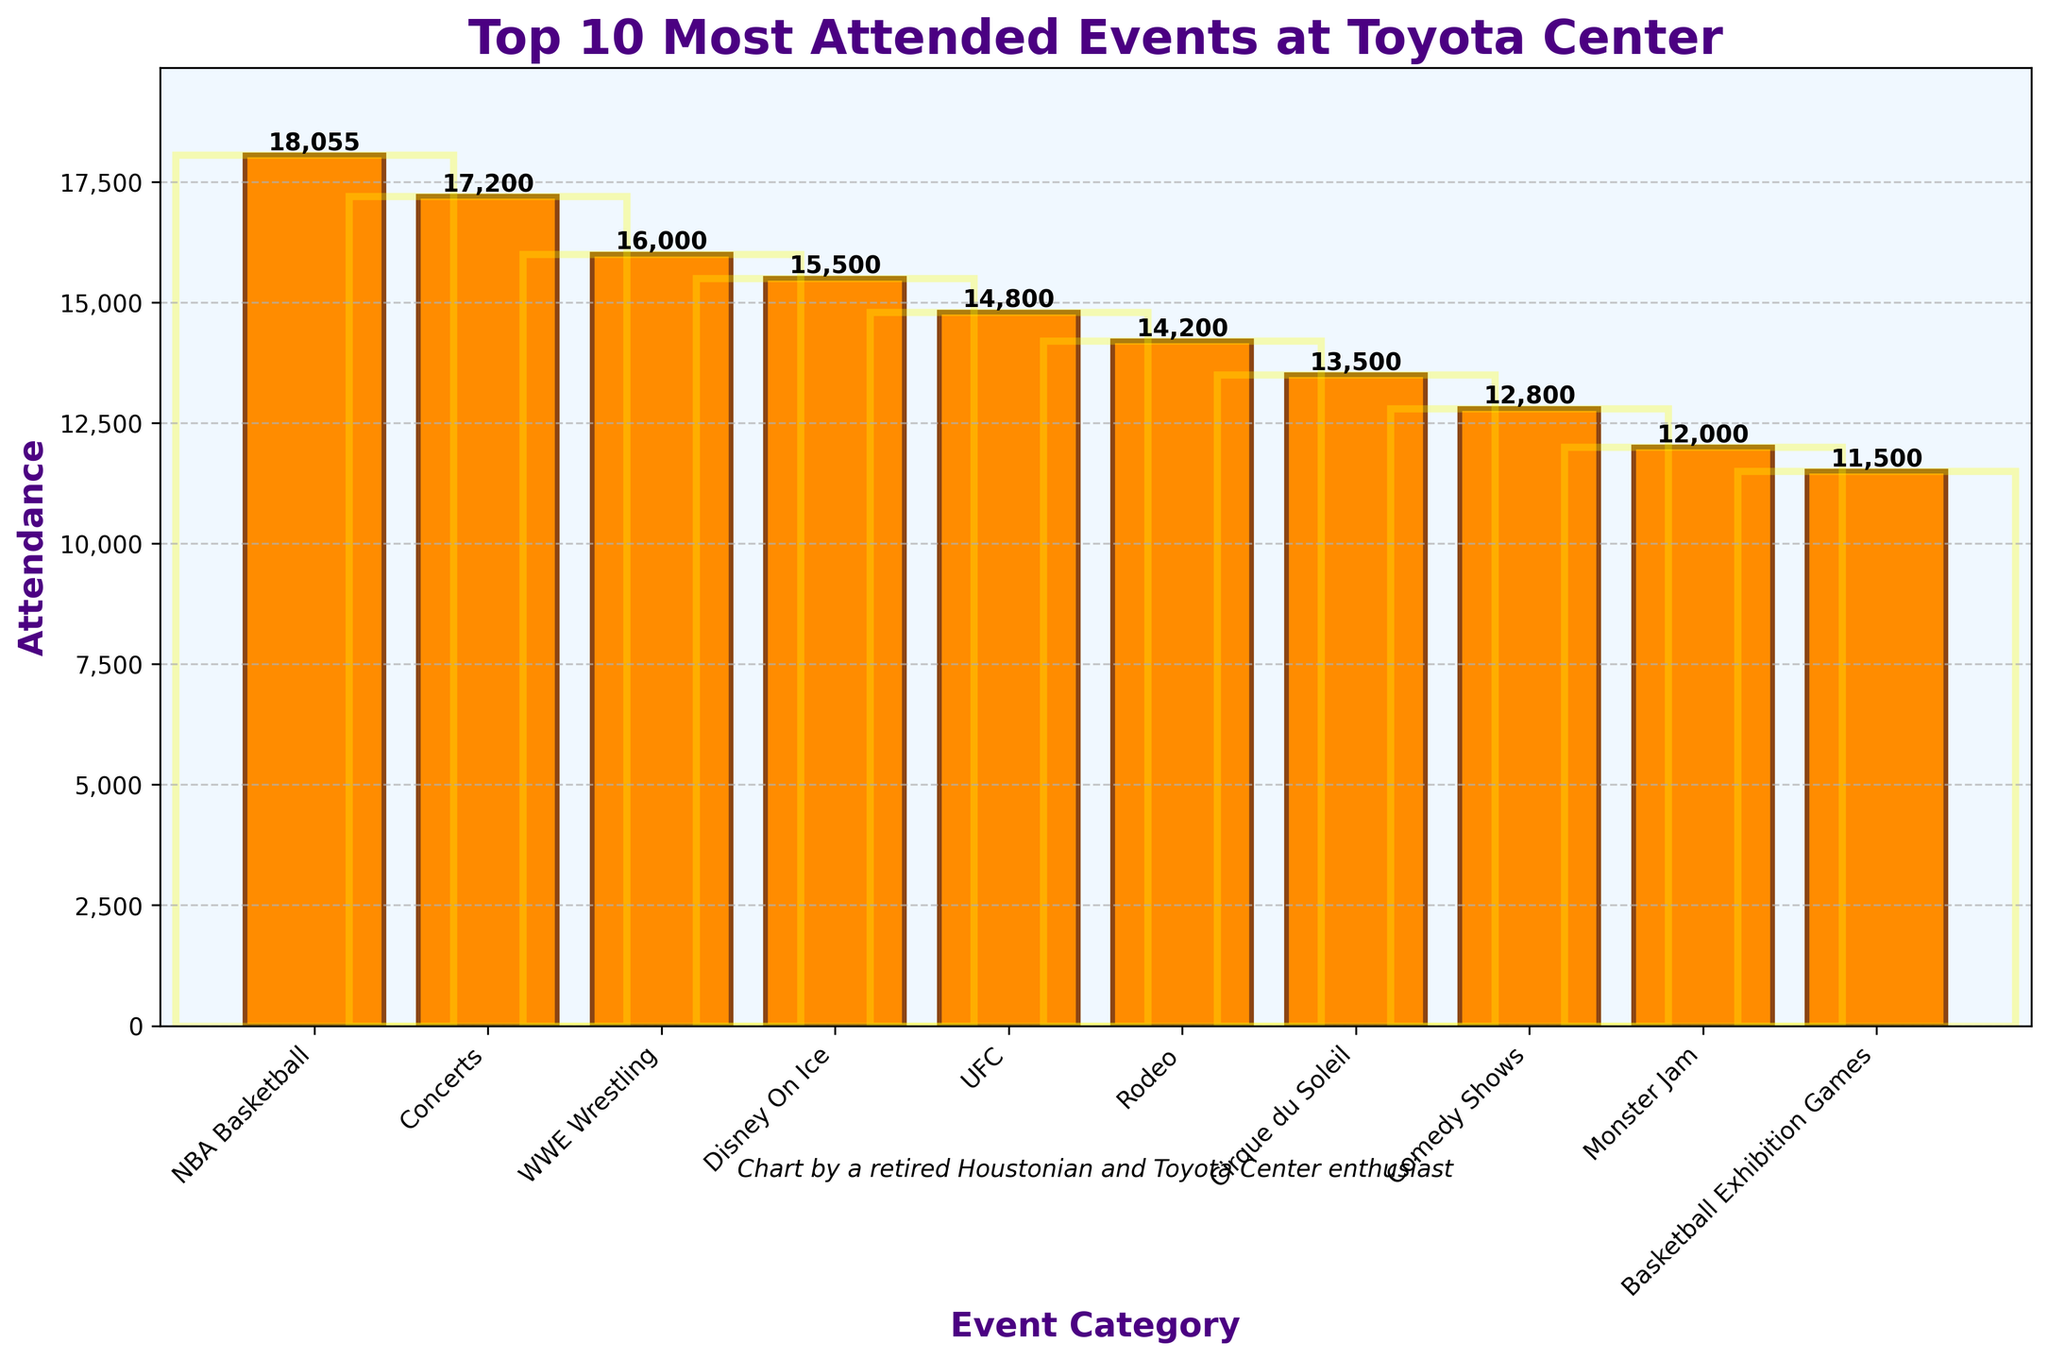Which event category had the highest attendance? The figure shows bars representing different event categories and their attendance. The tallest bar corresponds to the NBA Basketball category.
Answer: NBA Basketball What's the difference in attendance between the top two most attended events? The top two events are NBA Basketball (18,055) and Concerts (17,200). Subtracting their attendance gives 18055 - 17200 = 855.
Answer: 855 Which has higher attendance, WWE Wrestling or UFC? The height of the bars for WWE Wrestling and UFC shows that WWE Wrestling (16,000) has a higher attendance compared to UFC (14,800).
Answer: WWE Wrestling What is the average attendance of the top 3 most attended events? The top 3 events are NBA Basketball (18,055), Concerts (17,200), and WWE Wrestling (16,000). The average is calculated as (18055 + 17200 + 16000) / 3 = 17,085.
Answer: 17,085 How much higher is the attendance for Cirque du Soleil compared to Monster Jam? The attendance for Cirque du Soleil is 13,500 and for Monster Jam, it is 12,000. The difference is 13500 - 12000 = 1,500.
Answer: 1,500 What is the total attendance for the bottom 3 events? The bottom 3 events are Comedy Shows (12,800), Monster Jam (12,000), and Basketball Exhibition Games (11,500). The total is 12800 + 12000 + 11500 = 36,300.
Answer: 36,300 Which event category has the 5th highest attendance? By examining the height of the bars, the 5th highest attendance category is UFC with 14,800 attendees.
Answer: UFC What percentage of the highest attendance category's attendance is the Rodeo's attendance? The highest attendance category (NBA Basketball) has 18,055 and Rodeo has 14,200. The percentage is (14200 / 18055) * 100 ≈ 78.64%.
Answer: 78.64% Is the attendance for Disney On Ice more than the average attendance of Cirque du Soleil and Comedy Shows? The total attendance of Cirque du Soleil (13,500) and Comedy Shows (12,800) is 26,300. The average is 26300 / 2 = 13,150. Disney On Ice has 15,500 attendees, which is more than 13,150.
Answer: Yes How many categories have an attendance greater than 14,000? The categories with attendance greater than 14,000 are NBA Basketball, Concerts, WWE Wrestling, Disney On Ice, and UFC, totaling to 5 categories.
Answer: 5 